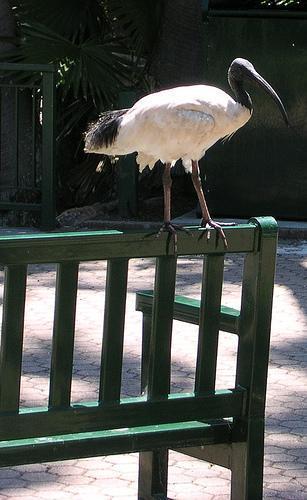How many benches are there in this picture?
Give a very brief answer. 1. 